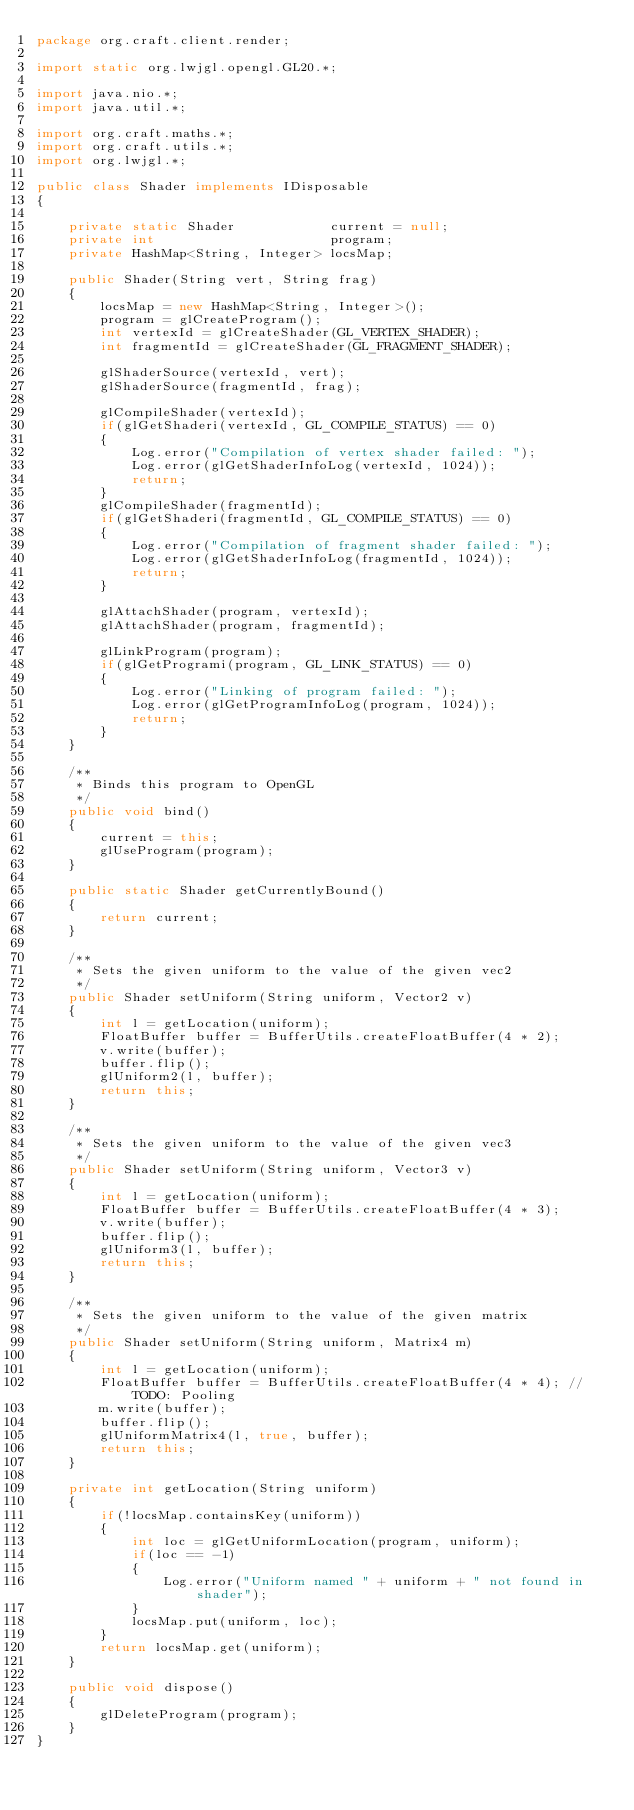Convert code to text. <code><loc_0><loc_0><loc_500><loc_500><_Java_>package org.craft.client.render;

import static org.lwjgl.opengl.GL20.*;

import java.nio.*;
import java.util.*;

import org.craft.maths.*;
import org.craft.utils.*;
import org.lwjgl.*;

public class Shader implements IDisposable
{

    private static Shader            current = null;
    private int                      program;
    private HashMap<String, Integer> locsMap;

    public Shader(String vert, String frag)
    {
        locsMap = new HashMap<String, Integer>();
        program = glCreateProgram();
        int vertexId = glCreateShader(GL_VERTEX_SHADER);
        int fragmentId = glCreateShader(GL_FRAGMENT_SHADER);

        glShaderSource(vertexId, vert);
        glShaderSource(fragmentId, frag);

        glCompileShader(vertexId);
        if(glGetShaderi(vertexId, GL_COMPILE_STATUS) == 0)
        {
            Log.error("Compilation of vertex shader failed: ");
            Log.error(glGetShaderInfoLog(vertexId, 1024));
            return;
        }
        glCompileShader(fragmentId);
        if(glGetShaderi(fragmentId, GL_COMPILE_STATUS) == 0)
        {
            Log.error("Compilation of fragment shader failed: ");
            Log.error(glGetShaderInfoLog(fragmentId, 1024));
            return;
        }

        glAttachShader(program, vertexId);
        glAttachShader(program, fragmentId);

        glLinkProgram(program);
        if(glGetProgrami(program, GL_LINK_STATUS) == 0)
        {
            Log.error("Linking of program failed: ");
            Log.error(glGetProgramInfoLog(program, 1024));
            return;
        }
    }

    /**
     * Binds this program to OpenGL
     */
    public void bind()
    {
        current = this;
        glUseProgram(program);
    }

    public static Shader getCurrentlyBound()
    {
        return current;
    }

    /**
     * Sets the given uniform to the value of the given vec2
     */
    public Shader setUniform(String uniform, Vector2 v)
    {
        int l = getLocation(uniform);
        FloatBuffer buffer = BufferUtils.createFloatBuffer(4 * 2);
        v.write(buffer);
        buffer.flip();
        glUniform2(l, buffer);
        return this;
    }

    /**
     * Sets the given uniform to the value of the given vec3
     */
    public Shader setUniform(String uniform, Vector3 v)
    {
        int l = getLocation(uniform);
        FloatBuffer buffer = BufferUtils.createFloatBuffer(4 * 3);
        v.write(buffer);
        buffer.flip();
        glUniform3(l, buffer);
        return this;
    }

    /**
     * Sets the given uniform to the value of the given matrix
     */
    public Shader setUniform(String uniform, Matrix4 m)
    {
        int l = getLocation(uniform);
        FloatBuffer buffer = BufferUtils.createFloatBuffer(4 * 4); // TODO: Pooling
        m.write(buffer);
        buffer.flip();
        glUniformMatrix4(l, true, buffer);
        return this;
    }

    private int getLocation(String uniform)
    {
        if(!locsMap.containsKey(uniform))
        {
            int loc = glGetUniformLocation(program, uniform);
            if(loc == -1)
            {
                Log.error("Uniform named " + uniform + " not found in shader");
            }
            locsMap.put(uniform, loc);
        }
        return locsMap.get(uniform);
    }

    public void dispose()
    {
        glDeleteProgram(program);
    }
}
</code> 